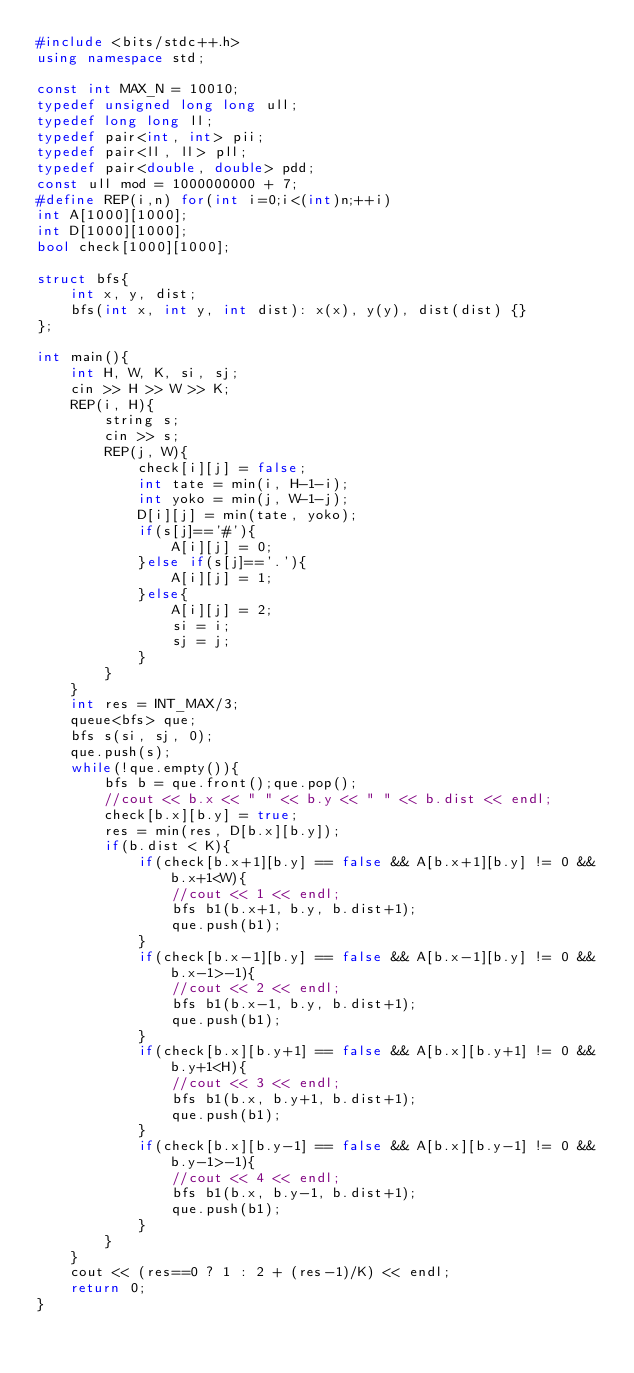<code> <loc_0><loc_0><loc_500><loc_500><_C++_>#include <bits/stdc++.h>
using namespace std;

const int MAX_N = 10010;
typedef unsigned long long ull;
typedef long long ll;
typedef pair<int, int> pii;
typedef pair<ll, ll> pll;
typedef pair<double, double> pdd;
const ull mod = 1000000000 + 7;
#define REP(i,n) for(int i=0;i<(int)n;++i)
int A[1000][1000];
int D[1000][1000];
bool check[1000][1000];

struct bfs{
    int x, y, dist;
    bfs(int x, int y, int dist): x(x), y(y), dist(dist) {}
};

int main(){
    int H, W, K, si, sj;
    cin >> H >> W >> K;
    REP(i, H){
        string s;
        cin >> s;
        REP(j, W){
            check[i][j] = false;
            int tate = min(i, H-1-i);
            int yoko = min(j, W-1-j);
            D[i][j] = min(tate, yoko);
            if(s[j]=='#'){
                A[i][j] = 0;
            }else if(s[j]=='.'){
                A[i][j] = 1;
            }else{
                A[i][j] = 2;
                si = i;
                sj = j;
            }
        }
    }
    int res = INT_MAX/3;
    queue<bfs> que;
    bfs s(si, sj, 0);
    que.push(s);
    while(!que.empty()){
        bfs b = que.front();que.pop();
        //cout << b.x << " " << b.y << " " << b.dist << endl;
        check[b.x][b.y] = true;
        res = min(res, D[b.x][b.y]);
        if(b.dist < K){
            if(check[b.x+1][b.y] == false && A[b.x+1][b.y] != 0 && b.x+1<W){
                //cout << 1 << endl;
                bfs b1(b.x+1, b.y, b.dist+1);
                que.push(b1);
            }
            if(check[b.x-1][b.y] == false && A[b.x-1][b.y] != 0 && b.x-1>-1){
                //cout << 2 << endl;
                bfs b1(b.x-1, b.y, b.dist+1);
                que.push(b1);
            }
            if(check[b.x][b.y+1] == false && A[b.x][b.y+1] != 0 && b.y+1<H){
                //cout << 3 << endl;
                bfs b1(b.x, b.y+1, b.dist+1);
                que.push(b1);
            }
            if(check[b.x][b.y-1] == false && A[b.x][b.y-1] != 0 && b.y-1>-1){
                //cout << 4 << endl;
                bfs b1(b.x, b.y-1, b.dist+1);
                que.push(b1);
            }
        }
    }
    cout << (res==0 ? 1 : 2 + (res-1)/K) << endl;
    return 0;
}</code> 